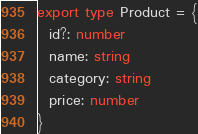<code> <loc_0><loc_0><loc_500><loc_500><_TypeScript_>export type Product = {
  id?: number
  name: string
  category: string
  price: number
}
</code> 